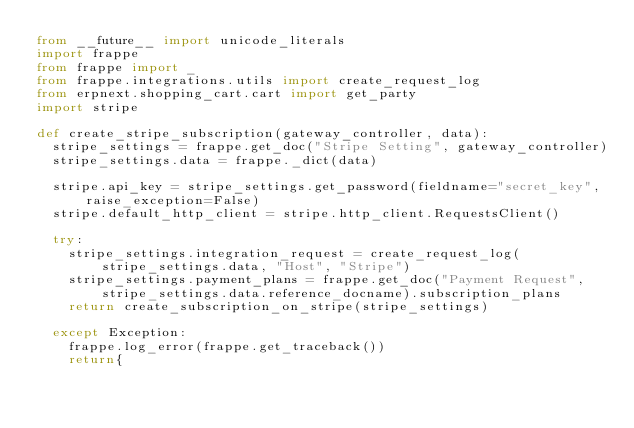<code> <loc_0><loc_0><loc_500><loc_500><_Python_>from __future__ import unicode_literals
import frappe
from frappe import _
from frappe.integrations.utils import create_request_log
from erpnext.shopping_cart.cart import get_party
import stripe

def create_stripe_subscription(gateway_controller, data):
	stripe_settings = frappe.get_doc("Stripe Setting", gateway_controller)
	stripe_settings.data = frappe._dict(data)

	stripe.api_key = stripe_settings.get_password(fieldname="secret_key", raise_exception=False)
	stripe.default_http_client = stripe.http_client.RequestsClient()

	try:
		stripe_settings.integration_request = create_request_log(stripe_settings.data, "Host", "Stripe")
		stripe_settings.payment_plans = frappe.get_doc("Payment Request", stripe_settings.data.reference_docname).subscription_plans
		return create_subscription_on_stripe(stripe_settings)

	except Exception:
		frappe.log_error(frappe.get_traceback())
		return{</code> 